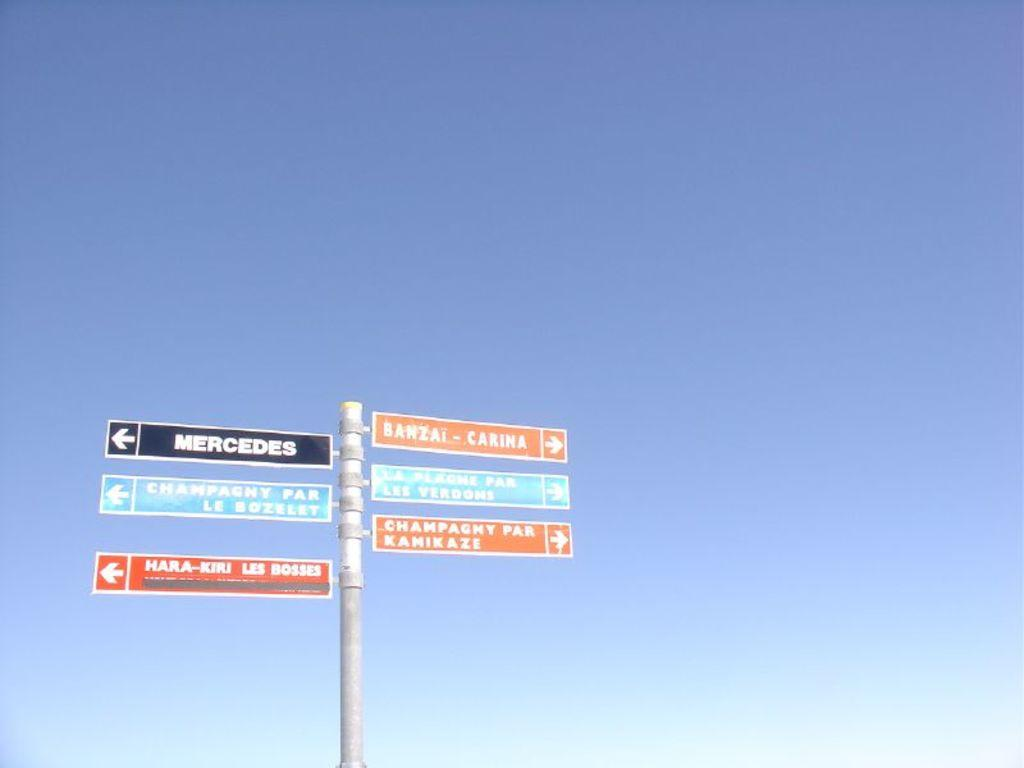<image>
Give a short and clear explanation of the subsequent image. A sign that has the word Mercedes on the top left of it 